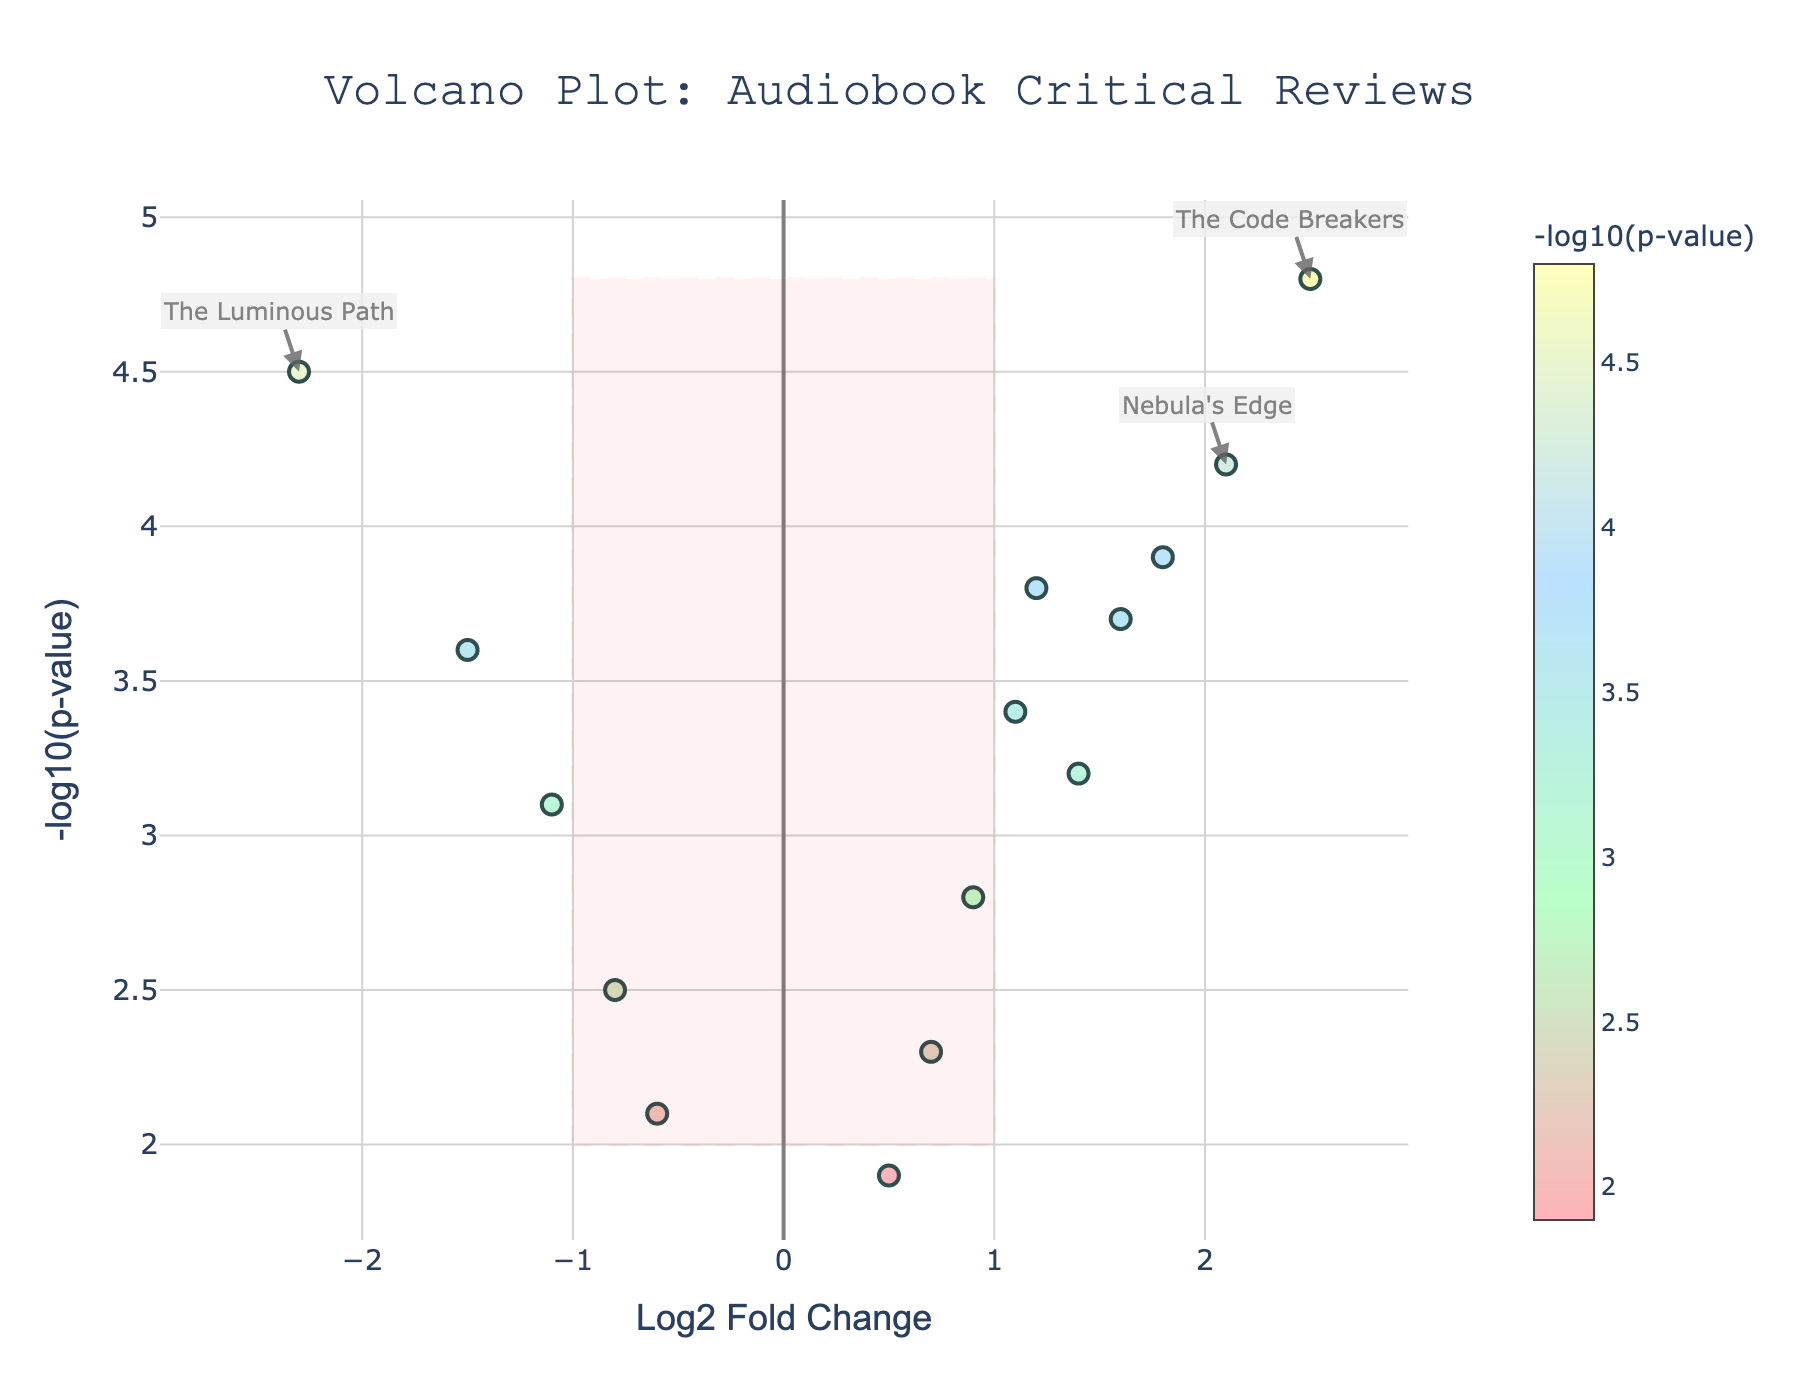What is the title of the plot? The title of the plot is usually located at the top center of the figure. By looking at the figure, you can read the title directly.
Answer: Volcano Plot: Audiobook Critical Reviews What does the x-axis represent? The x-axis usually has a label that describes what it represents. Looking at the figure, we can see that it is labeled "Log2 Fold Change," indicating this axis shows the Log2 Fold Change values of the data points.
Answer: Log2 Fold Change How many outliers are highlighted in the plot? Outliers are typically annotated and visually distinct. By counting these annotated points on the figure, we can determine the number of outliers. There are three annotations from the data provided.
Answer: 3 Is "Nebula's Edge" an outlier? By analyzing the annotations in the plot, we can see that one of them corresponds to "Nebula's Edge," indicating it is indeed an outlier.
Answer: Yes Which production type has a more outlier count, Professional or Author-read? By reviewing the annotated outliers and their corresponding production types, we can count and compare. From the data, "Nebula's Edge" is Professional, "The Luminous Path" and "The Code Breakers" are Author-read, thus Author-read has more outliers.
Answer: Author-read Which book has the highest -log10(p-value)? The -log10(p-value) is plotted on the y-axis. By finding the highest point on the y-axis, you can identify the corresponding book. It is "The Code Breakers" with a -log10(p-value) of 4.8.
Answer: The Code Breakers Does "The Silent Witness" have a positive or negative Log2 Fold Change? By locating "The Silent Witness" on the plot and observing its position relative to the y-axis, we see that it's to the left side, indicating a negative Log2 Fold Change.
Answer: Negative Which genre has the lowest Log2 Fold Change? By examining the position of points on the x-axis, we determine that the point with the lowest Log2 Fold Change is on the far left. "The Luminous Path" in the Literary Fiction genre has the lowest value of -2.3.
Answer: Literary Fiction How many books have a negative Log2 Fold Change? Points with negative Log2 Fold Change are located to the left of the y-axis. By counting these points, we find there are four books.
Answer: 4 Which book among the outliers has the lowest -log10(p-value)? By comparing the -log10(p-value) of annotated outliers, we see that "The Luminous Path" has the lowest value of 4.5 among the outliers.
Answer: The Luminous Path 